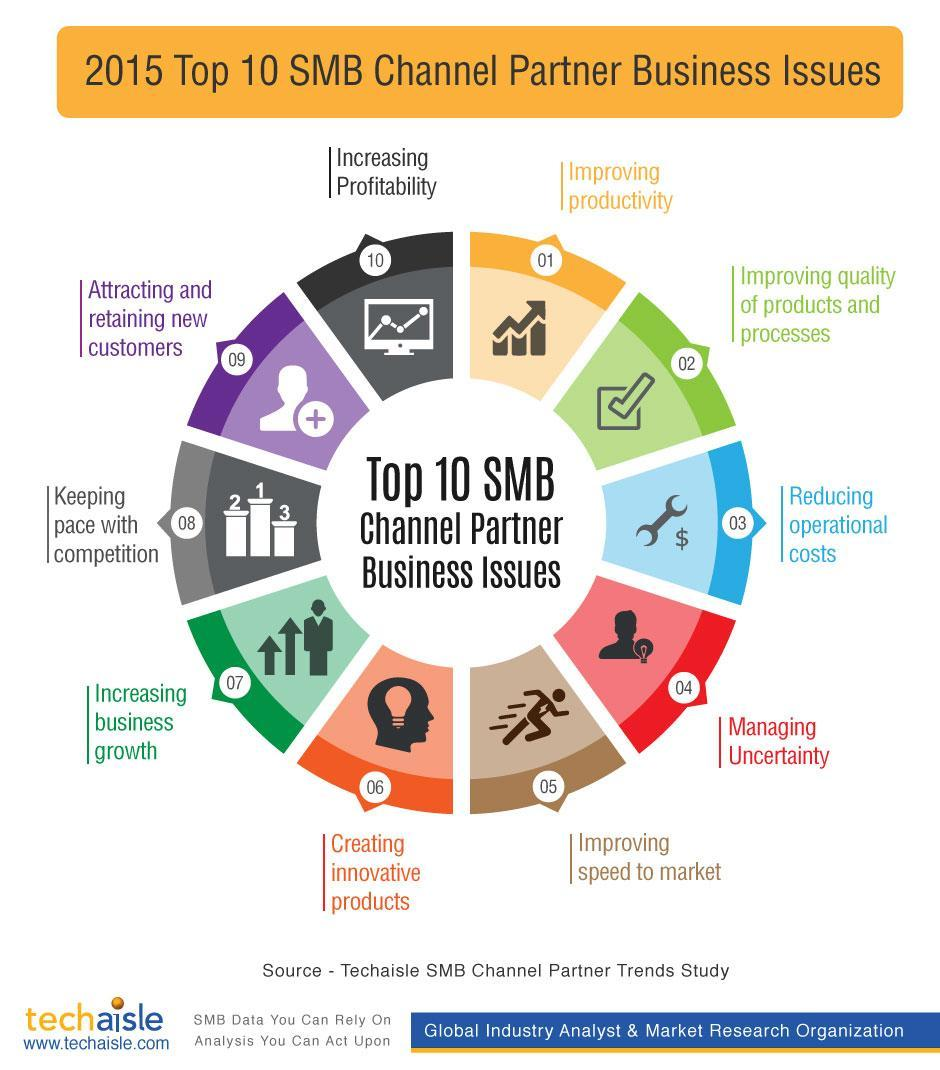Which is the fourth business issue mentioned in the infographic?
Answer the question with a short phrase. Managing Uncertainty What is the color code given to issue "Increasing Profitability"- green, blue, orange, black? black Which is the fifth business issue mentioned in the infographic? Improving speed to market What is the color code given to issue "Managing Uncertainty"- green, red, orange, yellow? red Which is the second business issue mentioned in the infographic? Improving quality of products and processes 